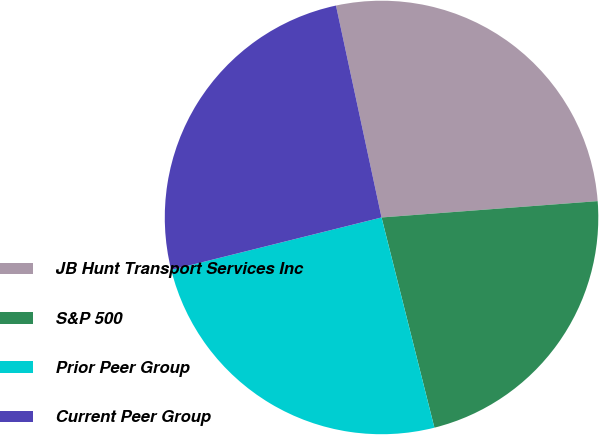<chart> <loc_0><loc_0><loc_500><loc_500><pie_chart><fcel>JB Hunt Transport Services Inc<fcel>S&P 500<fcel>Prior Peer Group<fcel>Current Peer Group<nl><fcel>27.17%<fcel>22.28%<fcel>25.03%<fcel>25.52%<nl></chart> 